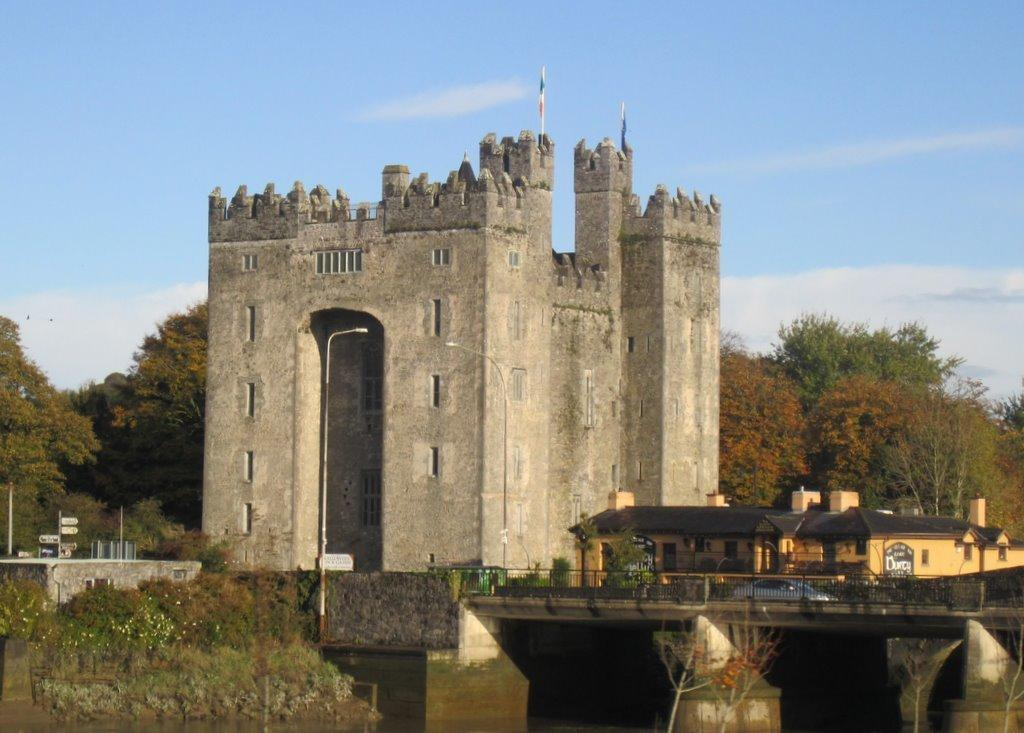What type of structure can be seen in the image? There is a bridge in the image. What is located near the bridge? There is a monument beside the bridge. What type of buildings are visible in the image? There are houses in the image. What can be seen in the background of the image? There are trees and a blue sky in the background of the image. What type of flesh can be seen cooking in the image? There is no flesh or cooking activity present in the image. How does the wind affect the bridge in the image? The image does not show any wind or its effects on the bridge. 